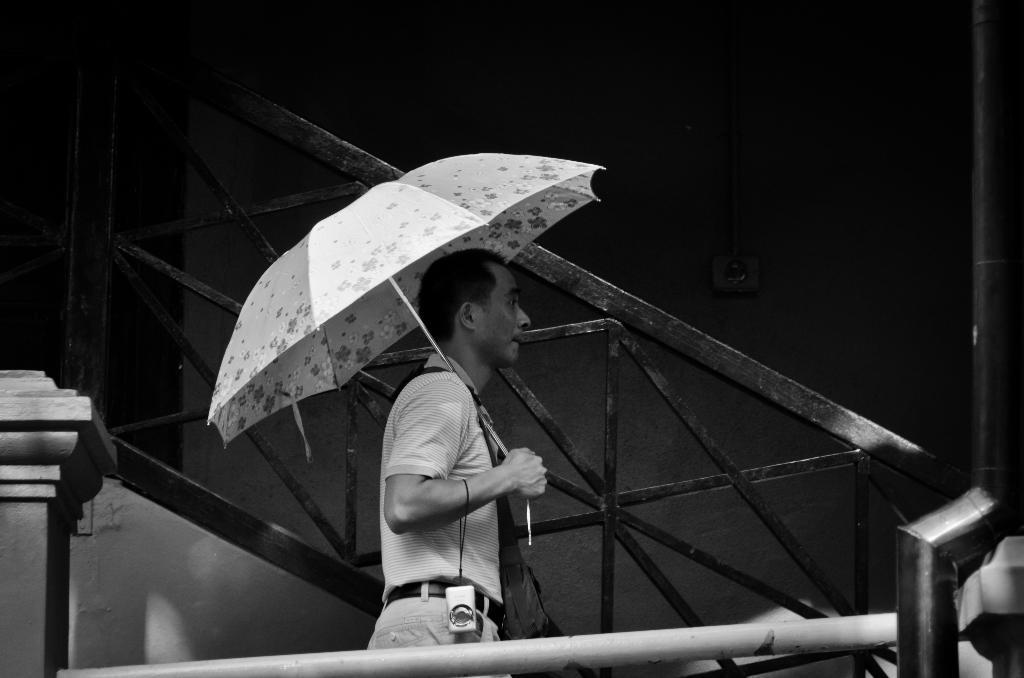Who is present in the image? There is a man in the image. What is the man doing in the image? The man is standing in the image. What object is the man holding in the image? The man is holding an umbrella in the image. What other object can be seen in the image? There is a camera in the image. What is the color scheme of the image? The image is black and white in color. What channel is the man watching on the television in the image? There is no television present in the image, so it is not possible to determine what channel the man might be watching. 